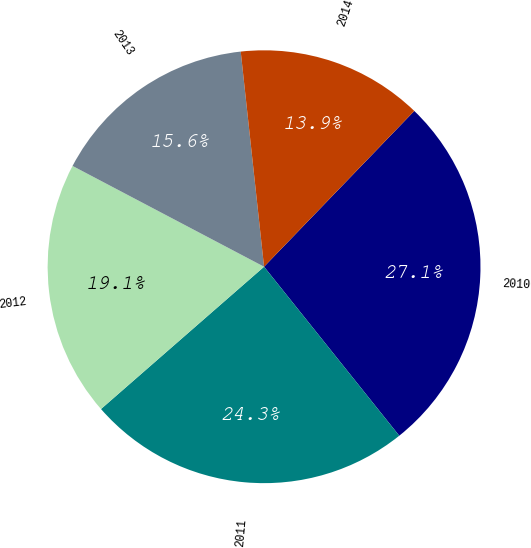Convert chart. <chart><loc_0><loc_0><loc_500><loc_500><pie_chart><fcel>2010<fcel>2011<fcel>2012<fcel>2013<fcel>2014<nl><fcel>27.05%<fcel>24.32%<fcel>19.13%<fcel>15.57%<fcel>13.93%<nl></chart> 